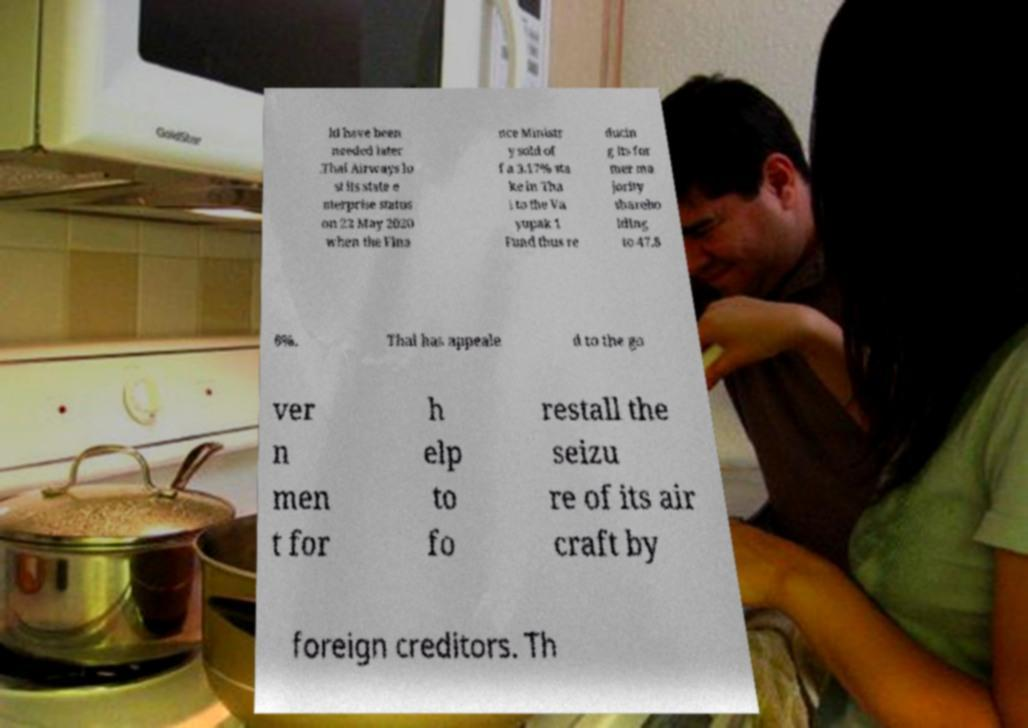Can you read and provide the text displayed in the image?This photo seems to have some interesting text. Can you extract and type it out for me? ld have been needed later .Thai Airways lo st its state e nterprise status on 22 May 2020 when the Fina nce Ministr y sold of f a 3.17% sta ke in Tha i to the Va yupak 1 Fund thus re ducin g its for mer ma jority shareho lding to 47.8 6%. Thai has appeale d to the go ver n men t for h elp to fo restall the seizu re of its air craft by foreign creditors. Th 